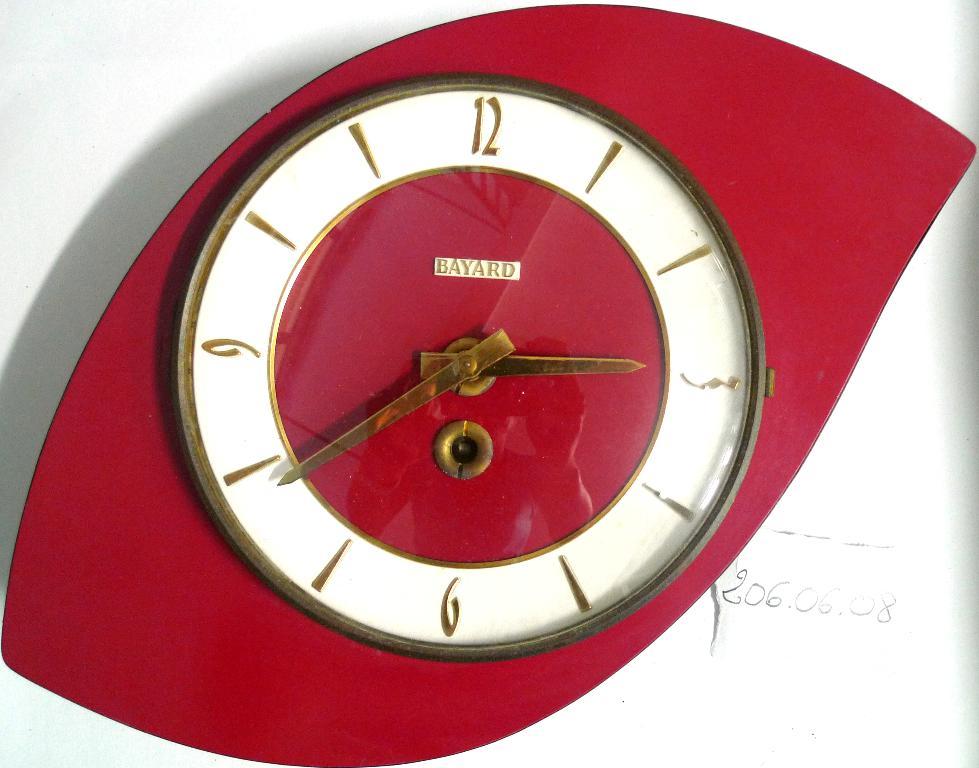What are the numbers written to the right of the clock?
Your answer should be compact. 206.06.08. What company logo in on the clock face?
Make the answer very short. Bayard. 